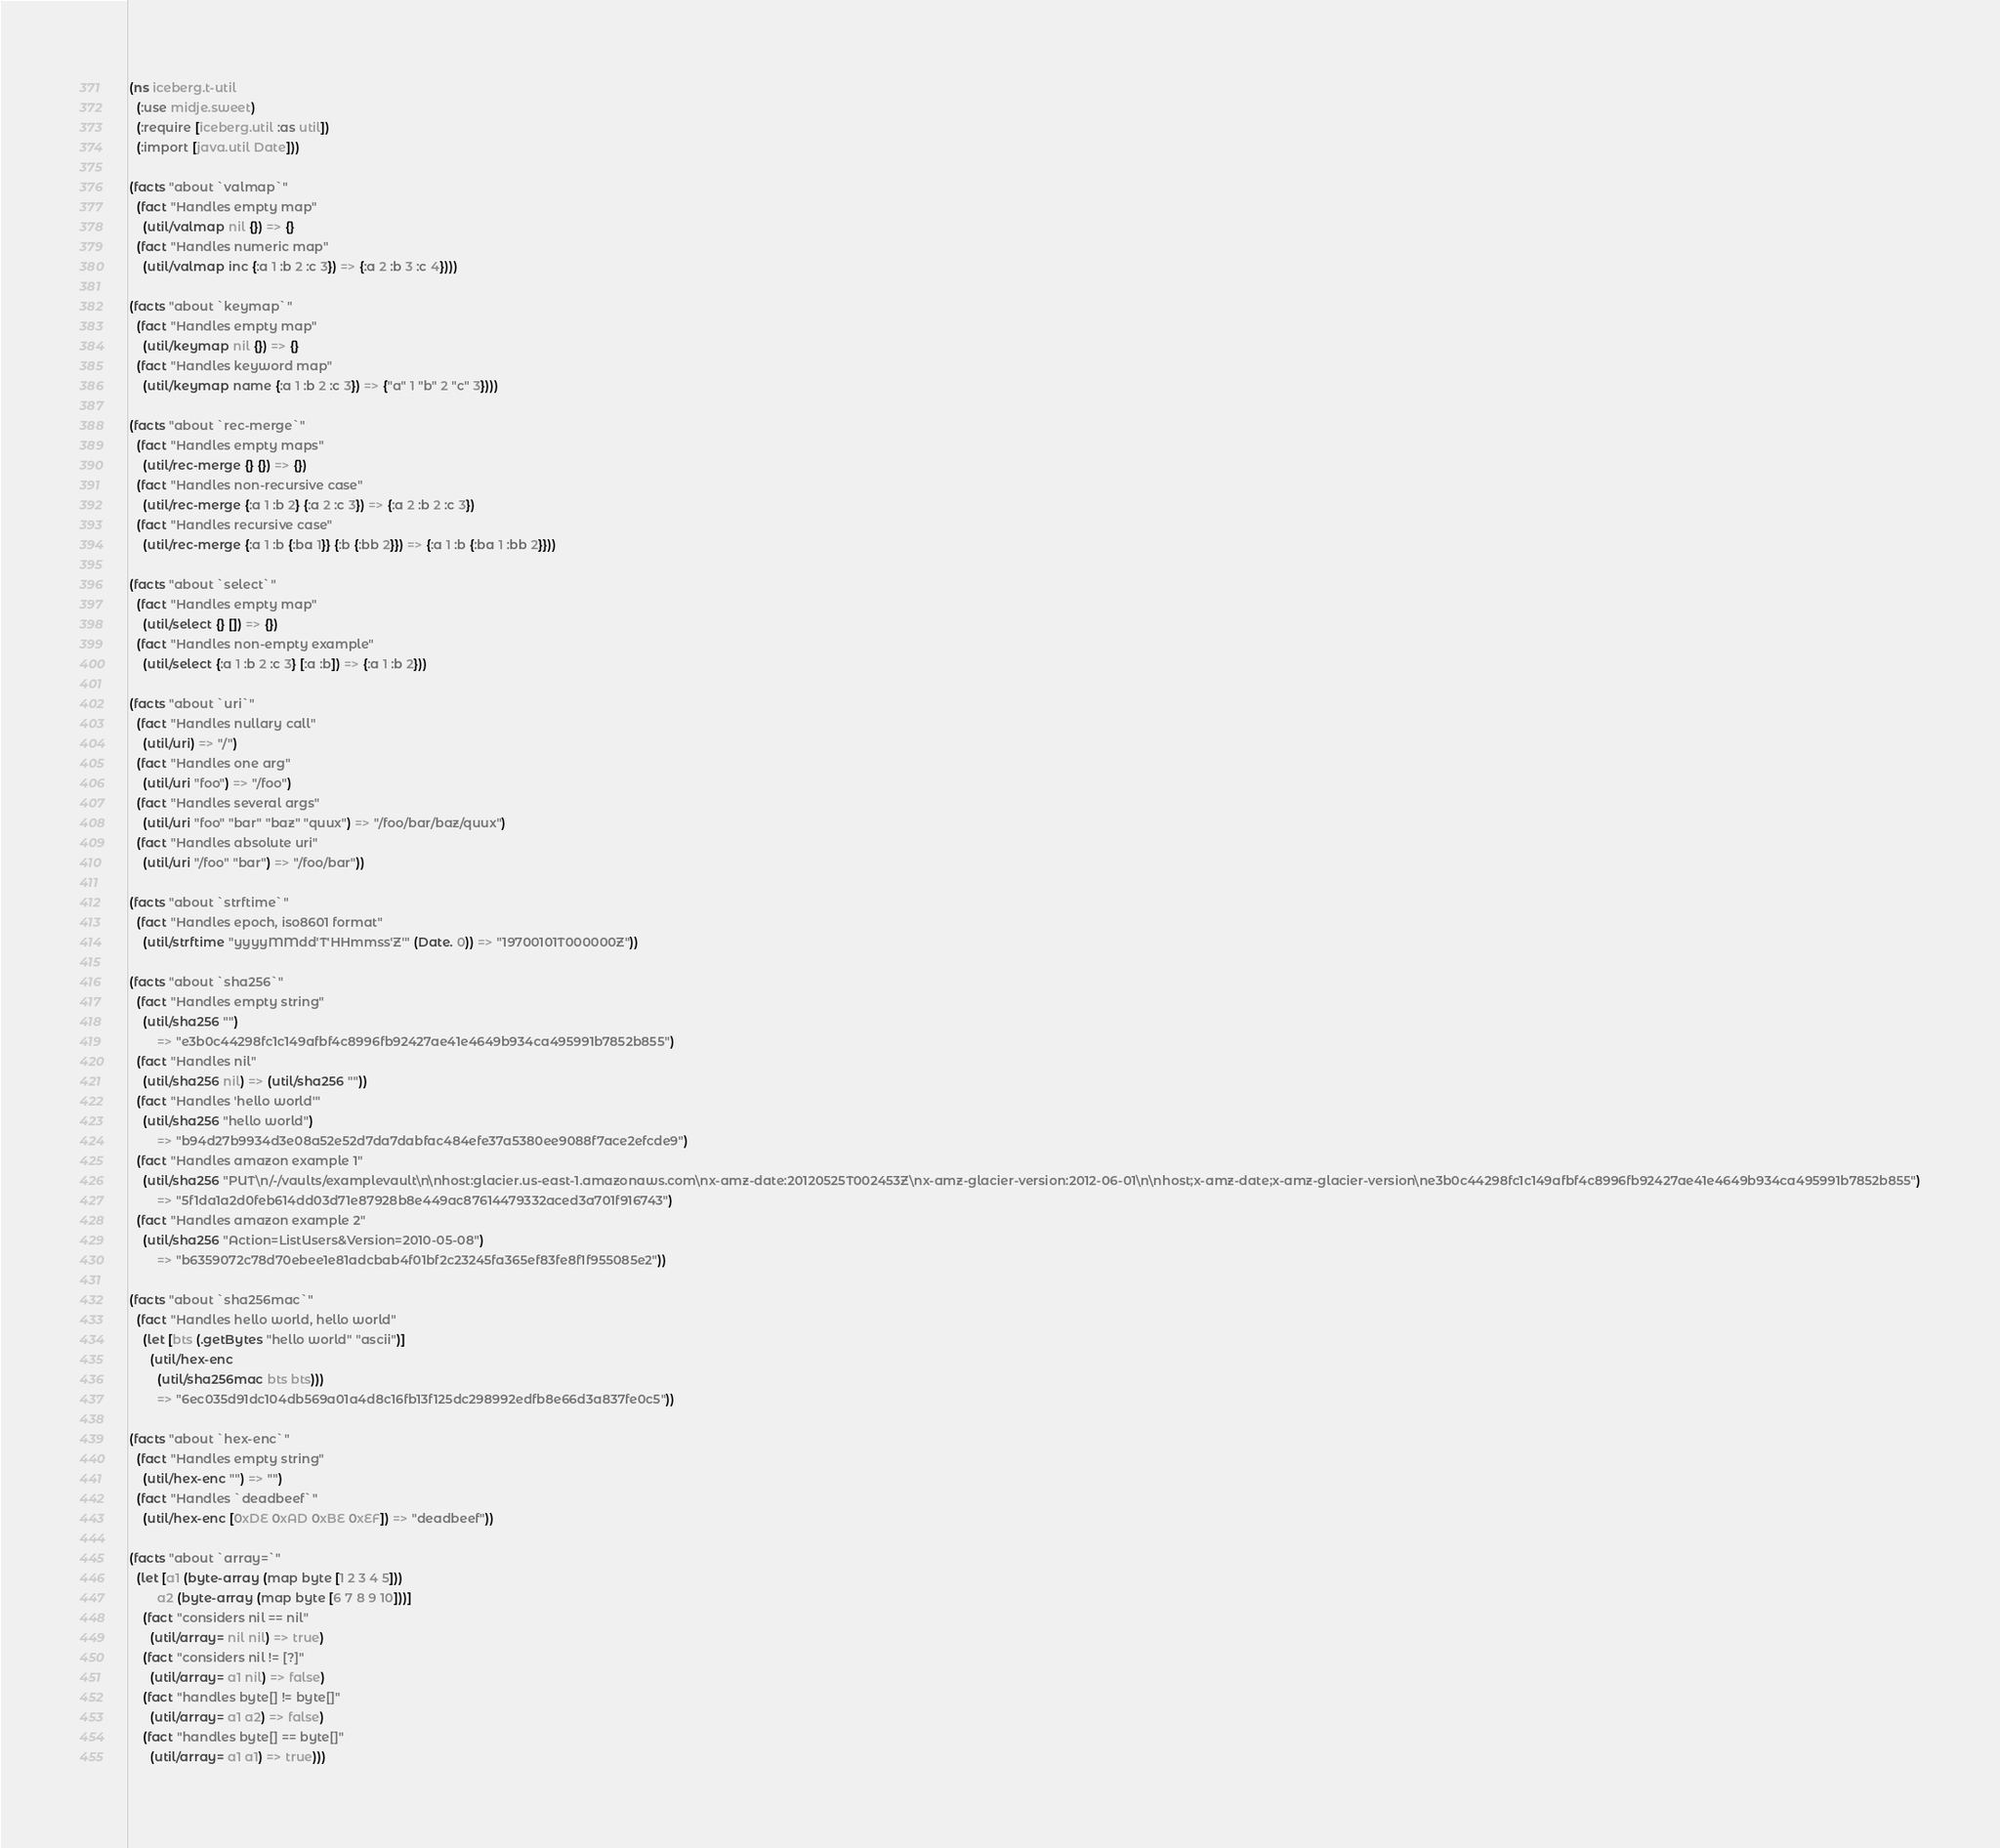Convert code to text. <code><loc_0><loc_0><loc_500><loc_500><_Clojure_>(ns iceberg.t-util
  (:use midje.sweet)
  (:require [iceberg.util :as util])
  (:import [java.util Date]))

(facts "about `valmap`"
  (fact "Handles empty map"
    (util/valmap nil {}) => {}
  (fact "Handles numeric map"
    (util/valmap inc {:a 1 :b 2 :c 3}) => {:a 2 :b 3 :c 4})))

(facts "about `keymap`"
  (fact "Handles empty map"
    (util/keymap nil {}) => {}
  (fact "Handles keyword map"
    (util/keymap name {:a 1 :b 2 :c 3}) => {"a" 1 "b" 2 "c" 3})))

(facts "about `rec-merge`"
  (fact "Handles empty maps"
    (util/rec-merge {} {}) => {})
  (fact "Handles non-recursive case"
    (util/rec-merge {:a 1 :b 2} {:a 2 :c 3}) => {:a 2 :b 2 :c 3})
  (fact "Handles recursive case"
    (util/rec-merge {:a 1 :b {:ba 1}} {:b {:bb 2}}) => {:a 1 :b {:ba 1 :bb 2}}))

(facts "about `select`"
  (fact "Handles empty map"
    (util/select {} []) => {})
  (fact "Handles non-empty example"
    (util/select {:a 1 :b 2 :c 3} [:a :b]) => {:a 1 :b 2}))

(facts "about `uri`"
  (fact "Handles nullary call"
    (util/uri) => "/")
  (fact "Handles one arg"
    (util/uri "foo") => "/foo")
  (fact "Handles several args"
    (util/uri "foo" "bar" "baz" "quux") => "/foo/bar/baz/quux")
  (fact "Handles absolute uri"
    (util/uri "/foo" "bar") => "/foo/bar"))

(facts "about `strftime`"
  (fact "Handles epoch, iso8601 format"
    (util/strftime "yyyyMMdd'T'HHmmss'Z'" (Date. 0)) => "19700101T000000Z"))

(facts "about `sha256`"
  (fact "Handles empty string"
    (util/sha256 "") 
        => "e3b0c44298fc1c149afbf4c8996fb92427ae41e4649b934ca495991b7852b855")
  (fact "Handles nil"
    (util/sha256 nil) => (util/sha256 ""))
  (fact "Handles 'hello world'"
    (util/sha256 "hello world")
        => "b94d27b9934d3e08a52e52d7da7dabfac484efe37a5380ee9088f7ace2efcde9")
  (fact "Handles amazon example 1"
    (util/sha256 "PUT\n/-/vaults/examplevault\n\nhost:glacier.us-east-1.amazonaws.com\nx-amz-date:20120525T002453Z\nx-amz-glacier-version:2012-06-01\n\nhost;x-amz-date;x-amz-glacier-version\ne3b0c44298fc1c149afbf4c8996fb92427ae41e4649b934ca495991b7852b855")
        => "5f1da1a2d0feb614dd03d71e87928b8e449ac87614479332aced3a701f916743")
  (fact "Handles amazon example 2"
    (util/sha256 "Action=ListUsers&Version=2010-05-08")
        => "b6359072c78d70ebee1e81adcbab4f01bf2c23245fa365ef83fe8f1f955085e2"))

(facts "about `sha256mac`"
  (fact "Handles hello world, hello world"
    (let [bts (.getBytes "hello world" "ascii")]
      (util/hex-enc 
        (util/sha256mac bts bts))) 
        => "6ec035d91dc104db569a01a4d8c16fb13f125dc298992edfb8e66d3a837fe0c5"))

(facts "about `hex-enc`"
  (fact "Handles empty string"
    (util/hex-enc "") => "")
  (fact "Handles `deadbeef`"
    (util/hex-enc [0xDE 0xAD 0xBE 0xEF]) => "deadbeef"))

(facts "about `array=`"
  (let [a1 (byte-array (map byte [1 2 3 4 5]))
        a2 (byte-array (map byte [6 7 8 9 10]))]
    (fact "considers nil == nil"
      (util/array= nil nil) => true)
    (fact "considers nil != [?]"
      (util/array= a1 nil) => false)
    (fact "handles byte[] != byte[]"
      (util/array= a1 a2) => false)
    (fact "handles byte[] == byte[]"
      (util/array= a1 a1) => true)))
</code> 